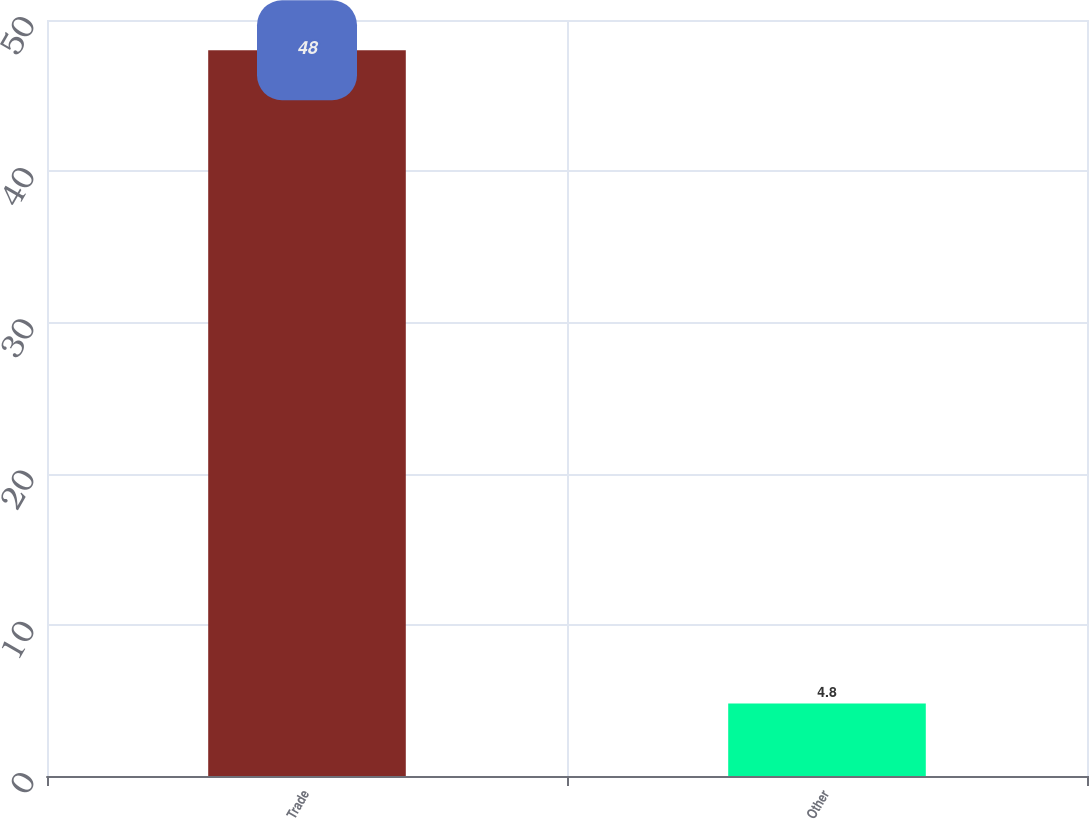<chart> <loc_0><loc_0><loc_500><loc_500><bar_chart><fcel>Trade<fcel>Other<nl><fcel>48<fcel>4.8<nl></chart> 